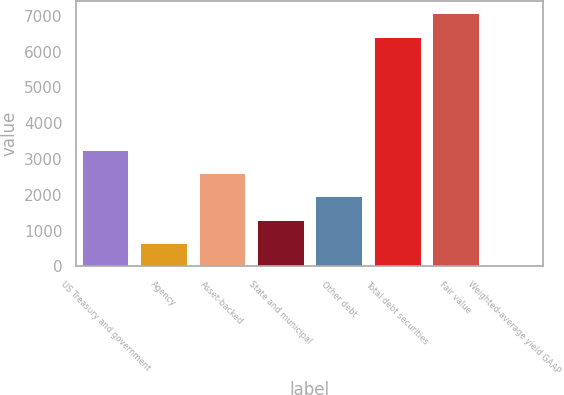Convert chart. <chart><loc_0><loc_0><loc_500><loc_500><bar_chart><fcel>US Treasury and government<fcel>Agency<fcel>Asset-backed<fcel>State and municipal<fcel>Other debt<fcel>Total debt securities<fcel>Fair value<fcel>Weighted-average yield GAAP<nl><fcel>3263.16<fcel>654.52<fcel>2611<fcel>1306.68<fcel>1958.84<fcel>6413<fcel>7065.16<fcel>2.36<nl></chart> 